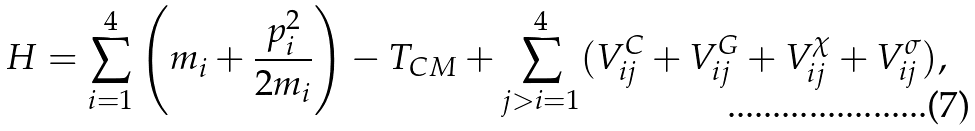Convert formula to latex. <formula><loc_0><loc_0><loc_500><loc_500>H = \sum _ { i = 1 } ^ { 4 } \left ( m _ { i } + \frac { p _ { i } ^ { 2 } } { 2 m _ { i } } \right ) - T _ { C M } + \sum _ { j > i = 1 } ^ { 4 } ( V _ { i j } ^ { C } + V _ { i j } ^ { G } + V _ { i j } ^ { \chi } + V _ { i j } ^ { \sigma } ) ,</formula> 